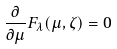Convert formula to latex. <formula><loc_0><loc_0><loc_500><loc_500>\frac { \partial } { \partial \mu } F _ { \lambda } ( \mu , \zeta ) = 0</formula> 